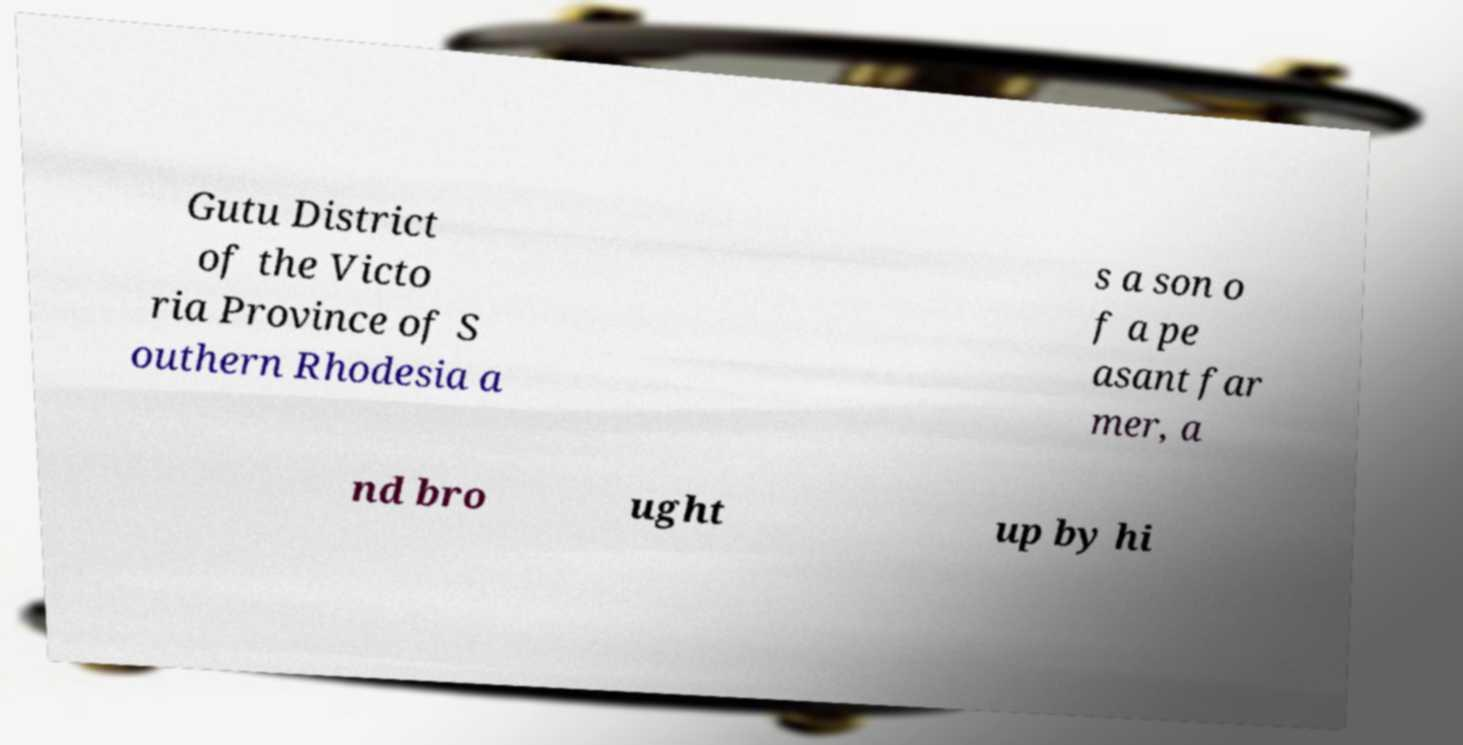Could you extract and type out the text from this image? Gutu District of the Victo ria Province of S outhern Rhodesia a s a son o f a pe asant far mer, a nd bro ught up by hi 